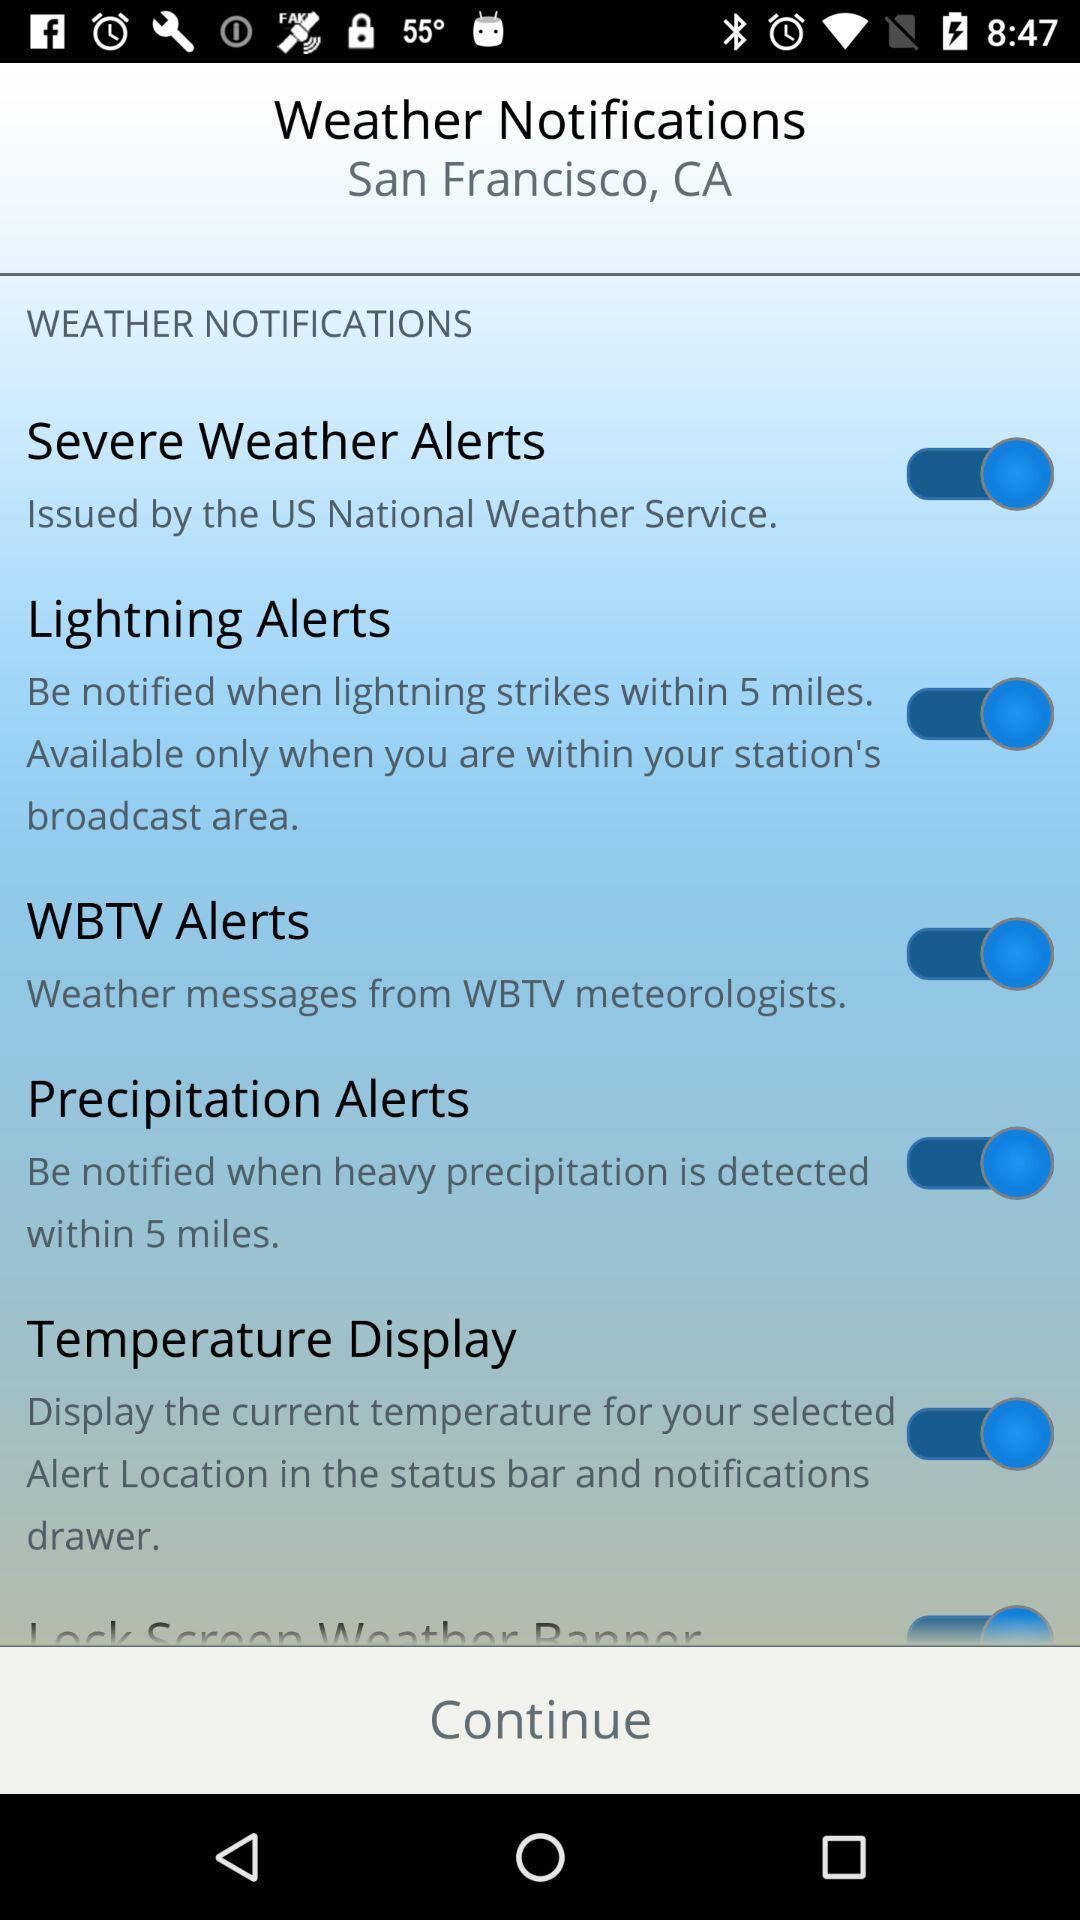What is the status of the "Lightning Alerts"? The status is "on". 